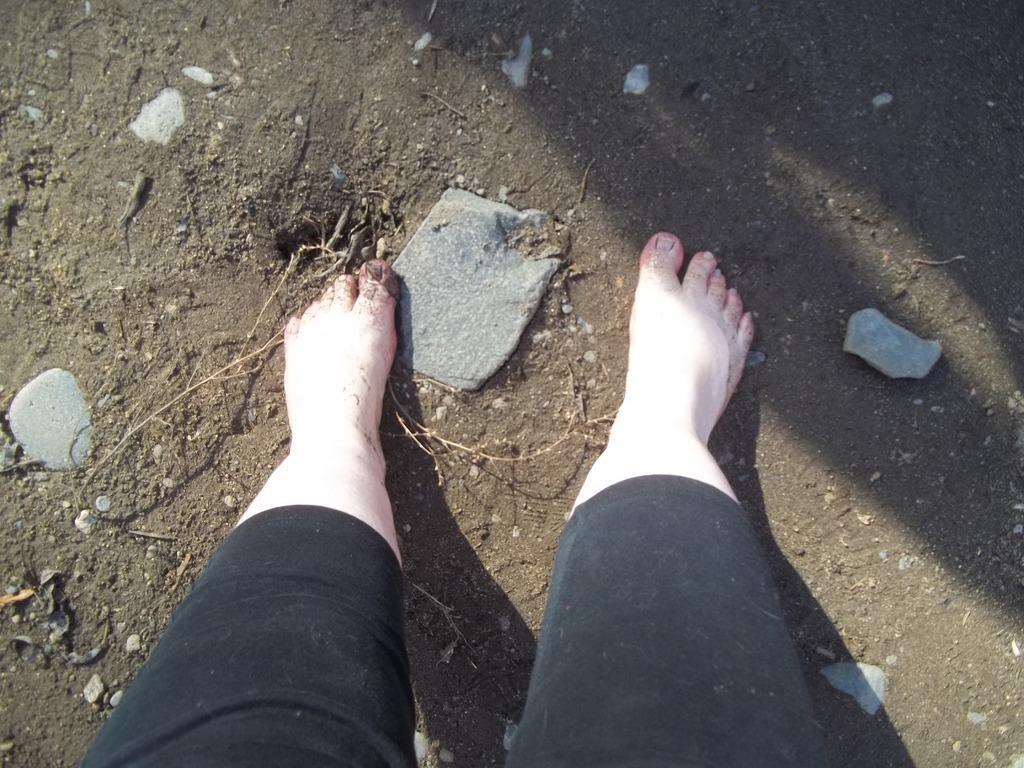Could you give a brief overview of what you see in this image? In the picture we can see a person's leg on the mud surface and on the mud surface we can see some stones. 